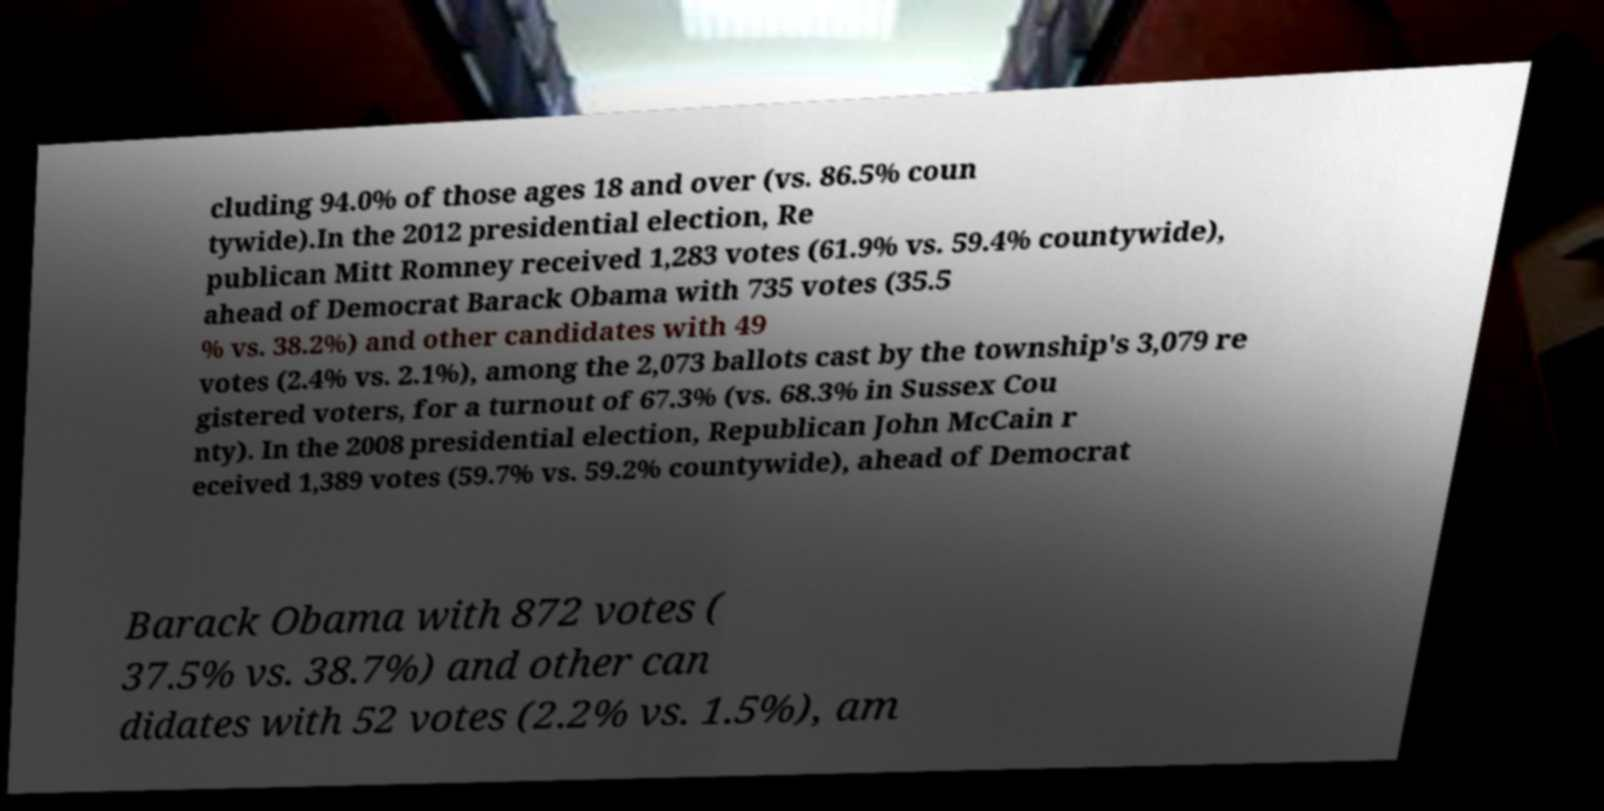Please read and relay the text visible in this image. What does it say? cluding 94.0% of those ages 18 and over (vs. 86.5% coun tywide).In the 2012 presidential election, Re publican Mitt Romney received 1,283 votes (61.9% vs. 59.4% countywide), ahead of Democrat Barack Obama with 735 votes (35.5 % vs. 38.2%) and other candidates with 49 votes (2.4% vs. 2.1%), among the 2,073 ballots cast by the township's 3,079 re gistered voters, for a turnout of 67.3% (vs. 68.3% in Sussex Cou nty). In the 2008 presidential election, Republican John McCain r eceived 1,389 votes (59.7% vs. 59.2% countywide), ahead of Democrat Barack Obama with 872 votes ( 37.5% vs. 38.7%) and other can didates with 52 votes (2.2% vs. 1.5%), am 